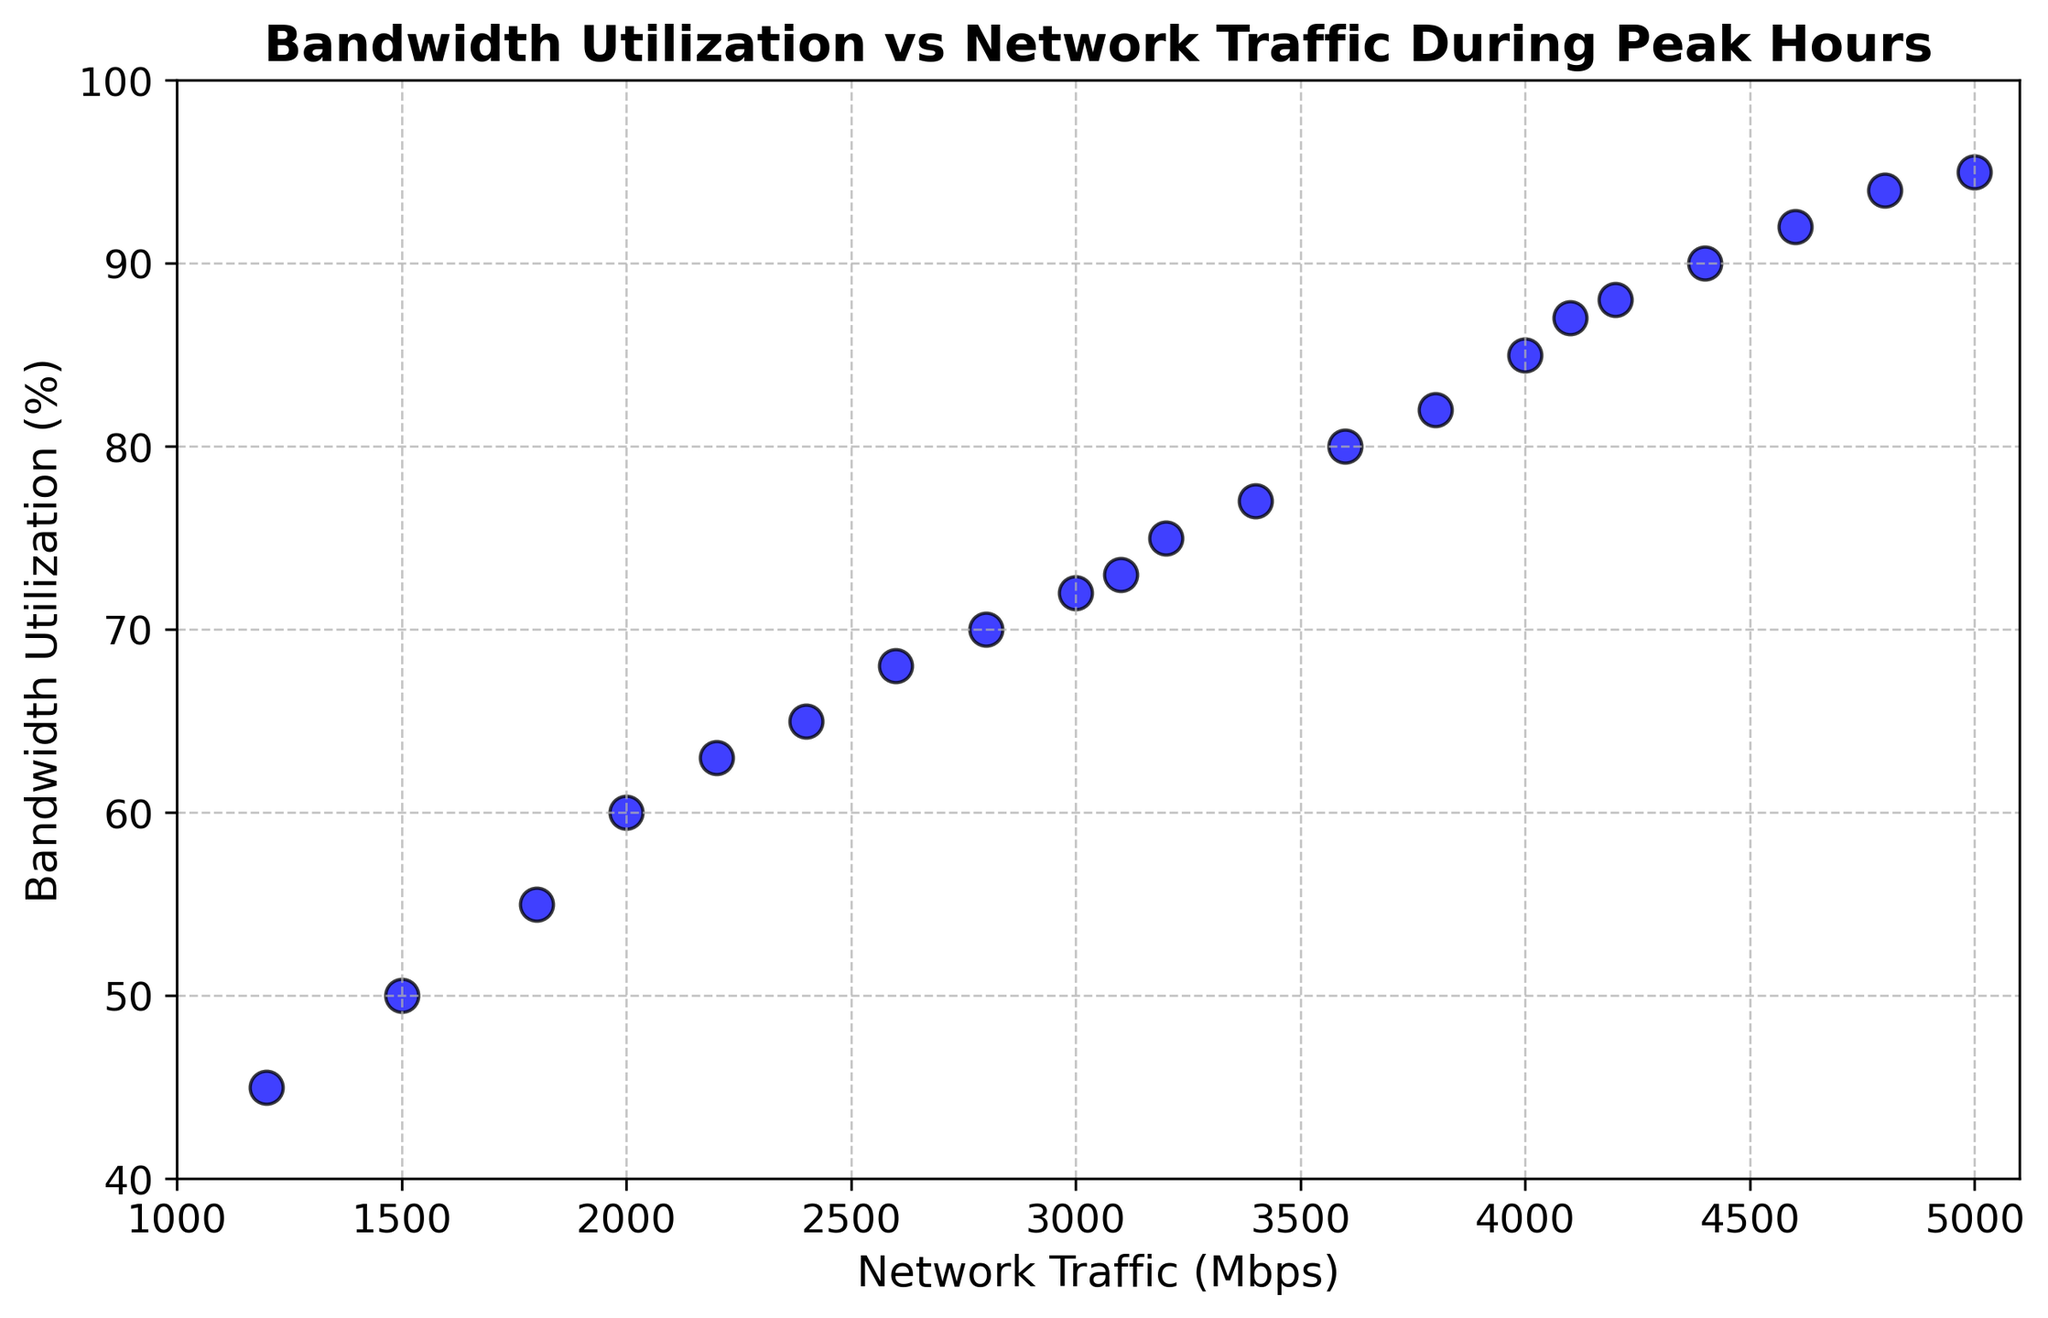Which time has the highest bandwidth utilization? To identify the highest bandwidth utilization, look for the highest point on the y-axis (Bandwidth Utilization) in the scatter plot.
Answer: 18:00 How does the bandwidth utilization at 10:00 compare to that at 15:00? Find the data points for 10:00 and 15:00 on the scatter plot, then compare their y-axis (Bandwidth Utilization) values.
Answer: 10:00 has a lower bandwidth utilization (63%) compared to 15:00 (85%) Is there a noticeable trend in the relationship between network traffic and bandwidth utilization? Observe the overall distribution of the data points on the scatter plot to see if there's an upward or downward trend.
Answer: Yes, there is an upward trend indicating that as network traffic increases, bandwidth utilization also increases What is the difference in network traffic between the time with the highest and lowest bandwidth utilization? Find the points corresponding to the highest and lowest bandwidth utilization, then calculate the difference between their x-axis (Network Traffic) values.
Answer: The difference is 3800 Mbps (5000 Mbps at 18:00 - 1200 Mbps at 08:00) By what percentage does bandwidth utilization increase from 12:00 to 18:00? Calculate the bandwidth utilization at 12:00 and 18:00 for the data points. Use the formula [(Final Value - Initial Value) / Initial Value] x 100% to find the percentage increase.
Answer: It increases by 31.94% What is the average network traffic between 08:00 and 10:00? Sum the network traffic values for 08:00, 08:30, 09:00, 09:30, and 10:00, then divide by the number of data points (5).
Answer: 1680 Mbps Which time slots experience a bandwidth utilization higher than 80%? Identify data points corresponding to bandwidth utilization values greater than 80% on the y-axis and match them to their respective times.
Answer: 14:00, 14:30, 15:00, 15:30, 16:00, 16:30, 17:00, 17:30, 18:00 